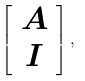<formula> <loc_0><loc_0><loc_500><loc_500>\left [ { \begin{array} { c } { A } \\ { I } \end{array} } \right ] ,</formula> 